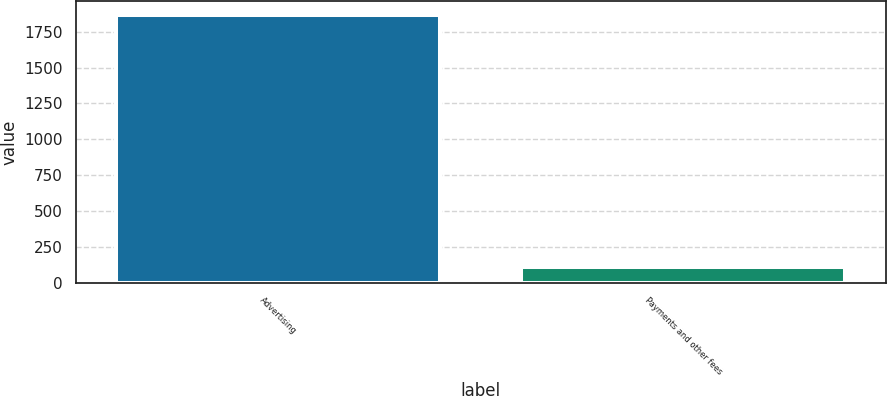Convert chart. <chart><loc_0><loc_0><loc_500><loc_500><bar_chart><fcel>Advertising<fcel>Payments and other fees<nl><fcel>1868<fcel>106<nl></chart> 